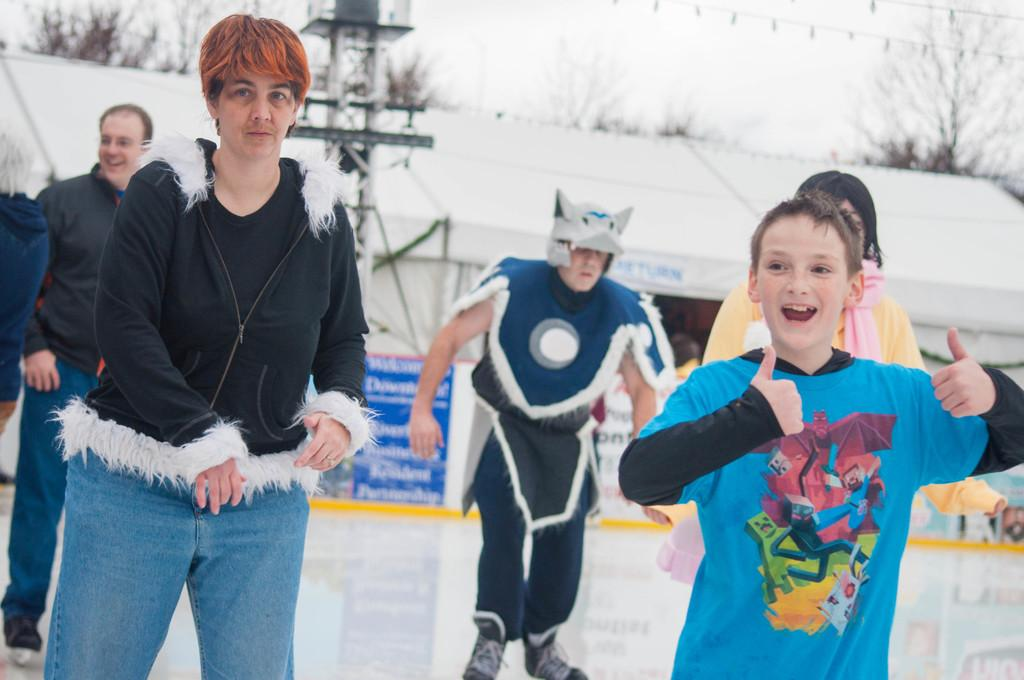Who or what is present in the image? There are people in the image. What can be seen in the background of the image? There is a tower, a building, a banner with text, trees, and the sky visible in the background of the image. How many actors are visible in the image? There is no mention of actors in the image, as the facts provided only mention people. 